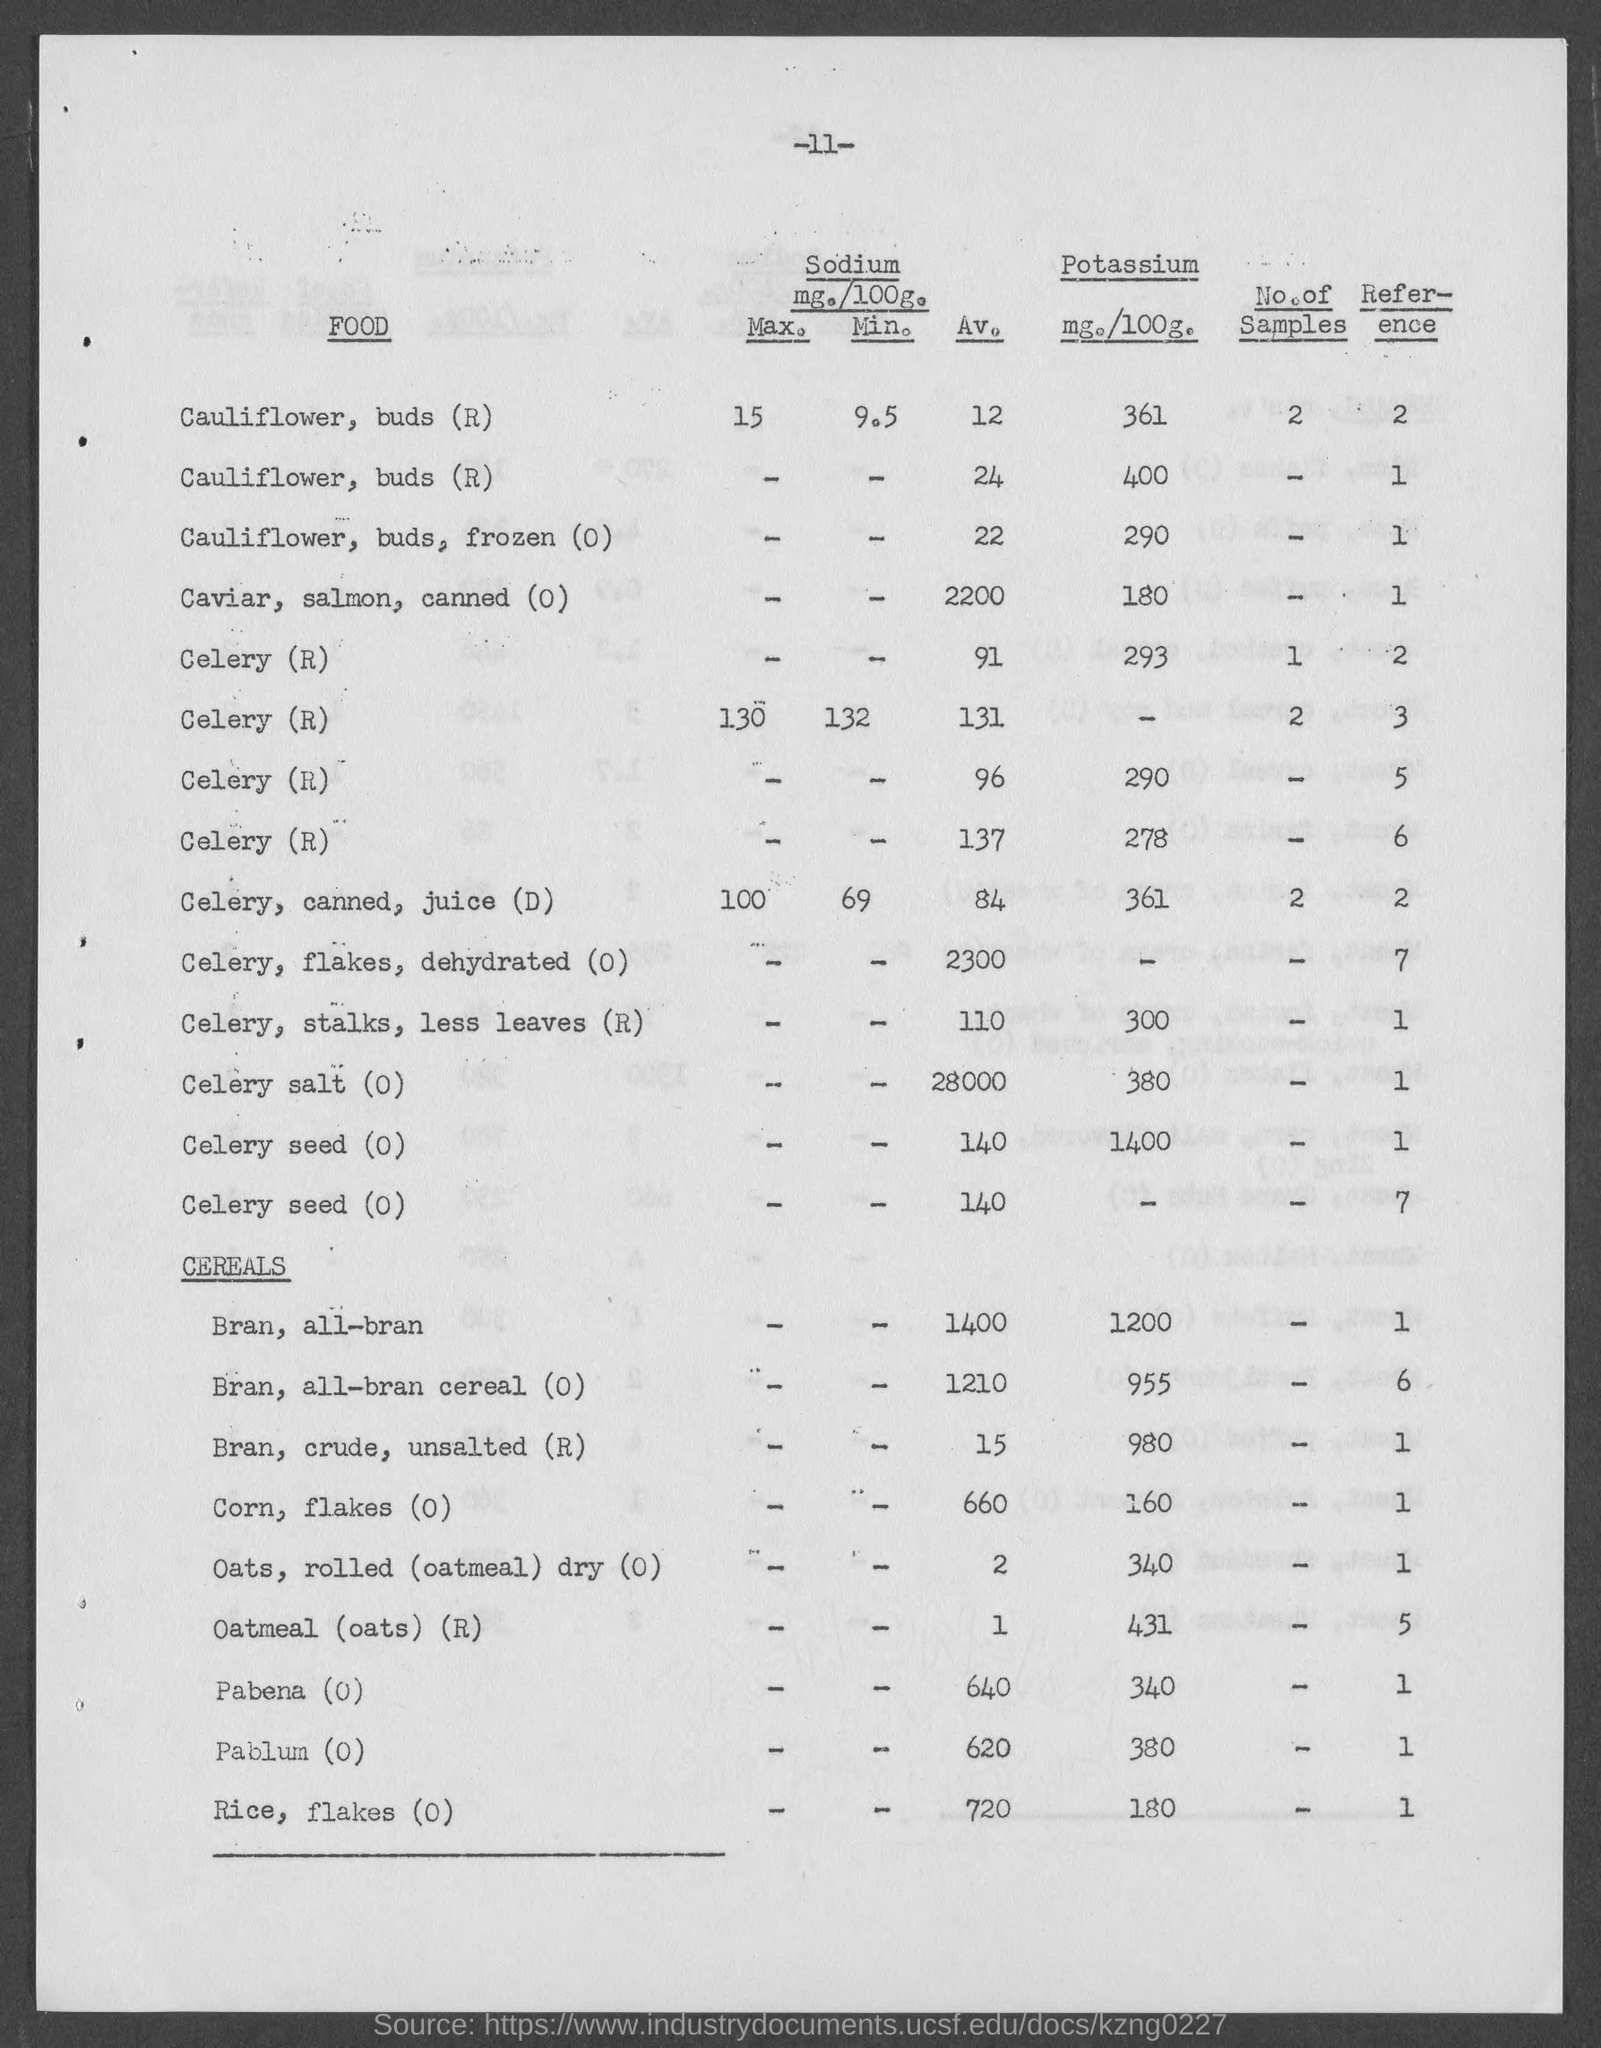Give some essential details in this illustration. Of the numbers in the "No. of Samples" column, the largest value is 2. Out of the food items listed, celery has no recorded value for potassium in the "mg./100g." column, as indicated by the letter "R" next to its name. The average sodium content in celery flakes, dehydrated (O) is 2300 mg/100g. The "mg./100g." value of potassium in "cauliflower, buds (r)," having an "Av." value of 12, is 361 milligrams per 100 grams. The reference value for the entry just above the subheading "cereals" is 7. 